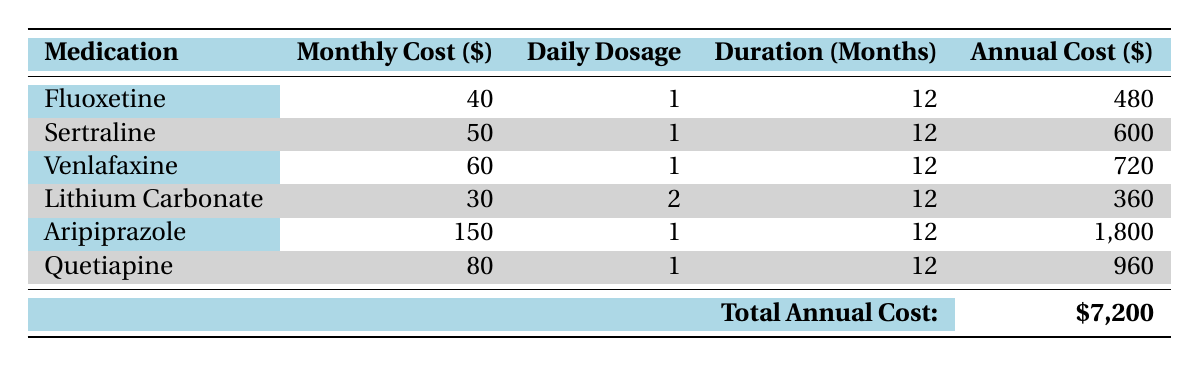What is the monthly cost of Aripiprazole? The table clearly states the monthly cost of Aripiprazole under the "Monthly Cost ($)" column, which is 150.
Answer: 150 What is the total annual cost of all the medications listed in the table? The total annual cost is provided directly in the last row, which sums up all individual medication costs to give a total of 7200.
Answer: 7200 Which medication has the lowest annual cost? By comparing the annual costs listed for each medication in the "Annual Cost ($)" column, Lithium Carbonate has the lowest annual cost at 360.
Answer: Lithium Carbonate If a patient takes both Fluoxetine and Quetiapine for one year, what is the combined annual cost? First, we identify the annual costs of Fluoxetine (480) and Quetiapine (960). Adding these gives 480 + 960 = 1440, which is the combined annual cost for both medications.
Answer: 1440 Is the monthly cost of Sertraline greater than that of Venlafaxine? The monthly cost of Sertraline is 50, while that of Venlafaxine is 60. Since 50 is not greater than 60, the answer is no.
Answer: No What is the total cost for all medications over the year if a patient only takes Lithium Carbonate? The cost for Lithium Carbonate over 12 months is listed as 360 in the "Annual Cost ($)" column, which is the total cost for the year.
Answer: 360 What is the average monthly cost of the medications? To find the average, we sum all monthly costs (40 + 50 + 60 + 30 + 150 + 80 = 410) and divide by the number of medications (6), which gives us 410 / 6 = approximately 68.33.
Answer: 68.33 Which two medications have the highest monthly cost, and what is their total? The highest monthly cost is for Aripiprazole (150) followed by Quetiapine (80). Adding these amounts gives 150 + 80 = 230.
Answer: 230 If a patient takes Venlafaxine for 6 months only, how much will it cost? The monthly cost of Venlafaxine is 60. Therefore, for 6 months, the total cost is 60 * 6 = 360.
Answer: 360 